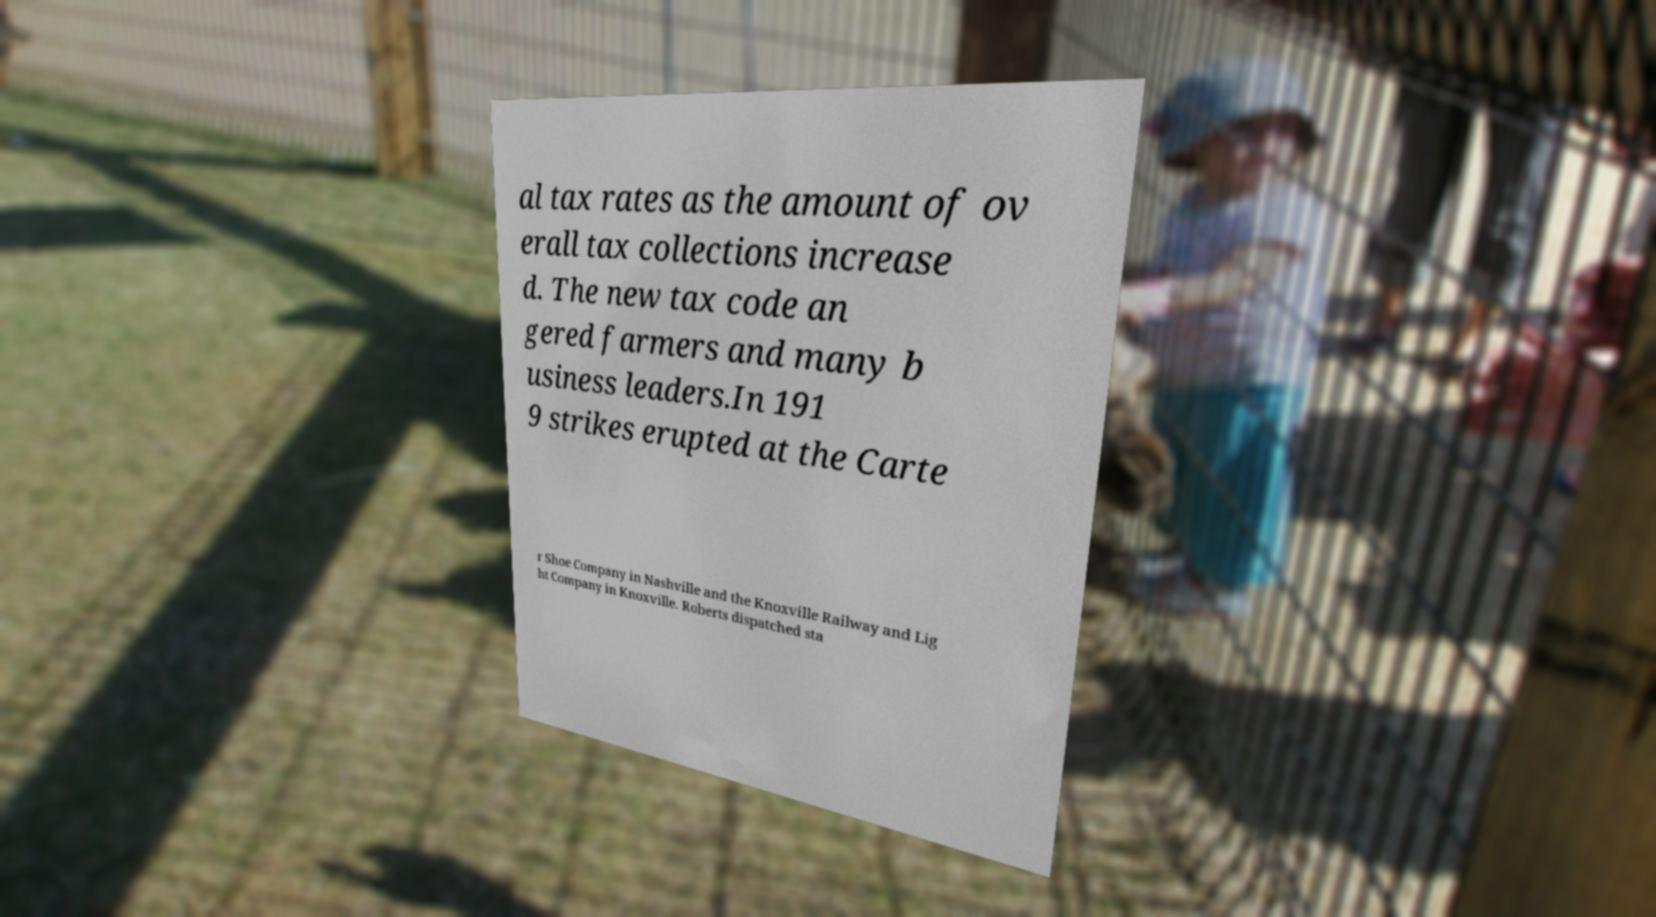Could you assist in decoding the text presented in this image and type it out clearly? al tax rates as the amount of ov erall tax collections increase d. The new tax code an gered farmers and many b usiness leaders.In 191 9 strikes erupted at the Carte r Shoe Company in Nashville and the Knoxville Railway and Lig ht Company in Knoxville. Roberts dispatched sta 